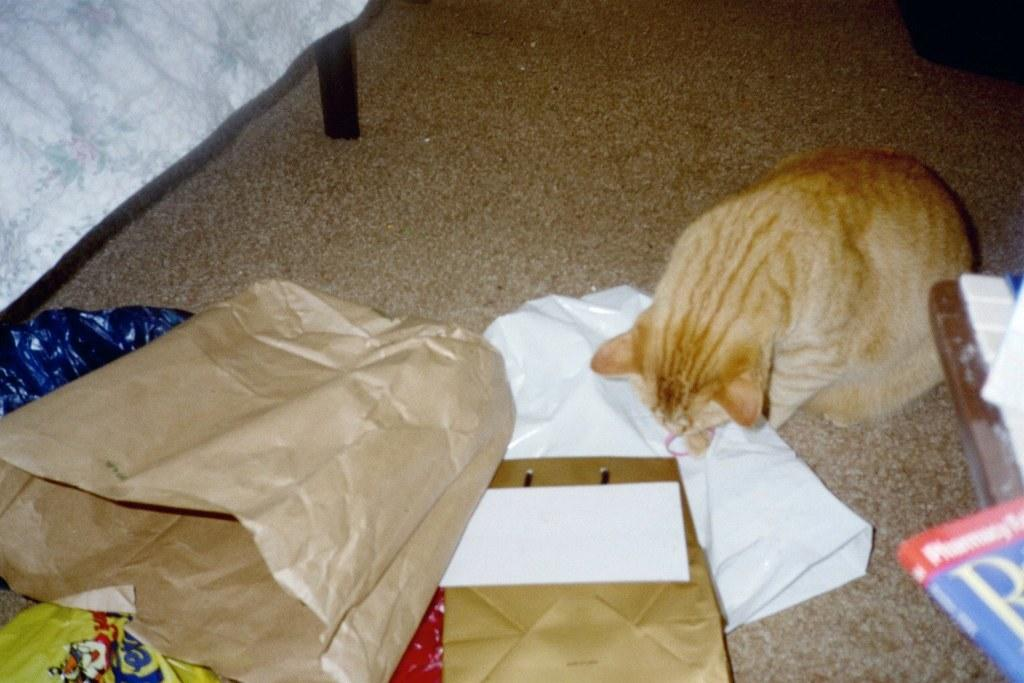What animal can be seen in the image? There is a cat in the image. Where is the cat located in the image? The cat is on the right side of the image. What objects are on the floor in front of the cat? There are paper bags on the floor in front of the cat. What can be seen on the right side of the image besides the cat? There is a book on a desk on the right side of the image. What is the value of the cat's smile in the image? There is no indication of the cat smiling in the image, and therefore no value can be assigned to its smile. 